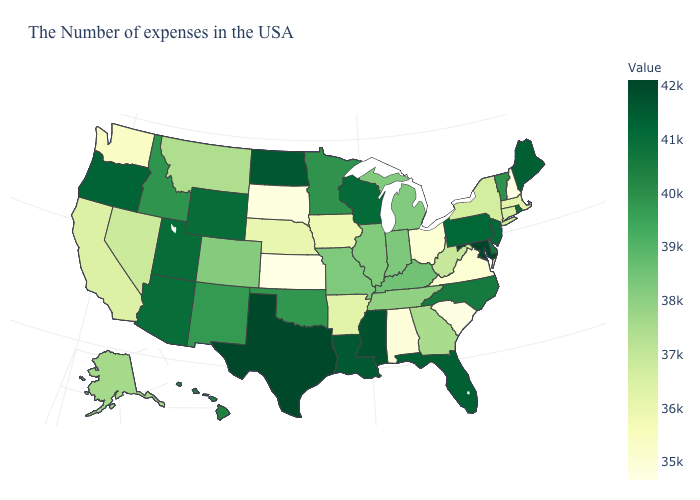Which states hav the highest value in the MidWest?
Be succinct. North Dakota. Among the states that border New Hampshire , which have the highest value?
Keep it brief. Maine. Which states have the highest value in the USA?
Write a very short answer. Maryland. Among the states that border North Carolina , does Georgia have the lowest value?
Short answer required. No. Does the map have missing data?
Quick response, please. No. Among the states that border Connecticut , does New York have the highest value?
Answer briefly. No. 